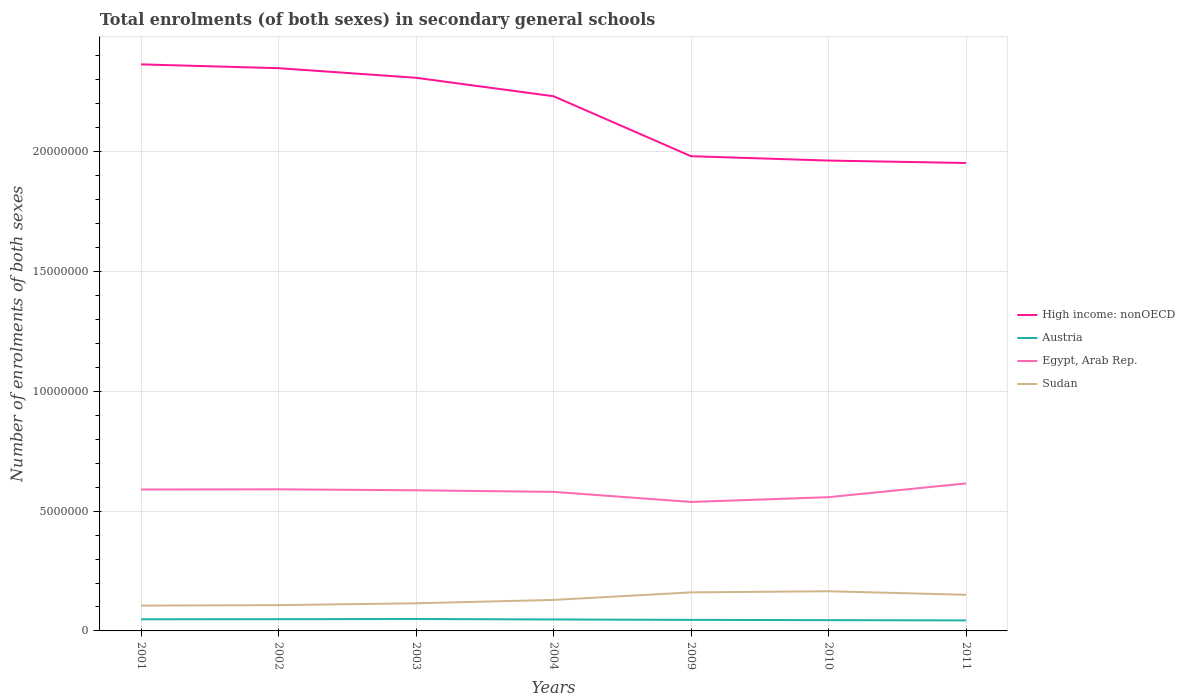How many different coloured lines are there?
Give a very brief answer. 4. Is the number of lines equal to the number of legend labels?
Offer a very short reply. Yes. Across all years, what is the maximum number of enrolments in secondary schools in Egypt, Arab Rep.?
Offer a very short reply. 5.38e+06. What is the total number of enrolments in secondary schools in Sudan in the graph?
Your response must be concise. -4.52e+05. What is the difference between the highest and the second highest number of enrolments in secondary schools in Austria?
Offer a terse response. 5.86e+04. Is the number of enrolments in secondary schools in Sudan strictly greater than the number of enrolments in secondary schools in Egypt, Arab Rep. over the years?
Offer a terse response. Yes. How many lines are there?
Offer a terse response. 4. How many years are there in the graph?
Provide a short and direct response. 7. What is the difference between two consecutive major ticks on the Y-axis?
Keep it short and to the point. 5.00e+06. Are the values on the major ticks of Y-axis written in scientific E-notation?
Your answer should be very brief. No. Where does the legend appear in the graph?
Ensure brevity in your answer.  Center right. How are the legend labels stacked?
Offer a very short reply. Vertical. What is the title of the graph?
Keep it short and to the point. Total enrolments (of both sexes) in secondary general schools. What is the label or title of the X-axis?
Keep it short and to the point. Years. What is the label or title of the Y-axis?
Your answer should be compact. Number of enrolments of both sexes. What is the Number of enrolments of both sexes in High income: nonOECD in 2001?
Give a very brief answer. 2.36e+07. What is the Number of enrolments of both sexes of Austria in 2001?
Give a very brief answer. 4.86e+05. What is the Number of enrolments of both sexes of Egypt, Arab Rep. in 2001?
Keep it short and to the point. 5.90e+06. What is the Number of enrolments of both sexes in Sudan in 2001?
Give a very brief answer. 1.06e+06. What is the Number of enrolments of both sexes in High income: nonOECD in 2002?
Keep it short and to the point. 2.35e+07. What is the Number of enrolments of both sexes in Austria in 2002?
Ensure brevity in your answer.  4.90e+05. What is the Number of enrolments of both sexes of Egypt, Arab Rep. in 2002?
Offer a very short reply. 5.91e+06. What is the Number of enrolments of both sexes of Sudan in 2002?
Keep it short and to the point. 1.08e+06. What is the Number of enrolments of both sexes in High income: nonOECD in 2003?
Ensure brevity in your answer.  2.31e+07. What is the Number of enrolments of both sexes in Austria in 2003?
Give a very brief answer. 4.98e+05. What is the Number of enrolments of both sexes in Egypt, Arab Rep. in 2003?
Provide a short and direct response. 5.87e+06. What is the Number of enrolments of both sexes of Sudan in 2003?
Your answer should be very brief. 1.15e+06. What is the Number of enrolments of both sexes in High income: nonOECD in 2004?
Keep it short and to the point. 2.23e+07. What is the Number of enrolments of both sexes of Austria in 2004?
Your answer should be compact. 4.78e+05. What is the Number of enrolments of both sexes of Egypt, Arab Rep. in 2004?
Your answer should be very brief. 5.80e+06. What is the Number of enrolments of both sexes in Sudan in 2004?
Ensure brevity in your answer.  1.29e+06. What is the Number of enrolments of both sexes of High income: nonOECD in 2009?
Ensure brevity in your answer.  1.98e+07. What is the Number of enrolments of both sexes of Austria in 2009?
Make the answer very short. 4.61e+05. What is the Number of enrolments of both sexes of Egypt, Arab Rep. in 2009?
Provide a succinct answer. 5.38e+06. What is the Number of enrolments of both sexes of Sudan in 2009?
Your answer should be compact. 1.61e+06. What is the Number of enrolments of both sexes in High income: nonOECD in 2010?
Give a very brief answer. 1.96e+07. What is the Number of enrolments of both sexes in Austria in 2010?
Your answer should be very brief. 4.50e+05. What is the Number of enrolments of both sexes in Egypt, Arab Rep. in 2010?
Your response must be concise. 5.58e+06. What is the Number of enrolments of both sexes of Sudan in 2010?
Offer a terse response. 1.66e+06. What is the Number of enrolments of both sexes in High income: nonOECD in 2011?
Provide a short and direct response. 1.95e+07. What is the Number of enrolments of both sexes in Austria in 2011?
Provide a succinct answer. 4.39e+05. What is the Number of enrolments of both sexes of Egypt, Arab Rep. in 2011?
Provide a succinct answer. 6.16e+06. What is the Number of enrolments of both sexes in Sudan in 2011?
Provide a succinct answer. 1.51e+06. Across all years, what is the maximum Number of enrolments of both sexes of High income: nonOECD?
Give a very brief answer. 2.36e+07. Across all years, what is the maximum Number of enrolments of both sexes of Austria?
Make the answer very short. 4.98e+05. Across all years, what is the maximum Number of enrolments of both sexes of Egypt, Arab Rep.?
Your answer should be very brief. 6.16e+06. Across all years, what is the maximum Number of enrolments of both sexes of Sudan?
Make the answer very short. 1.66e+06. Across all years, what is the minimum Number of enrolments of both sexes of High income: nonOECD?
Your answer should be compact. 1.95e+07. Across all years, what is the minimum Number of enrolments of both sexes in Austria?
Your response must be concise. 4.39e+05. Across all years, what is the minimum Number of enrolments of both sexes in Egypt, Arab Rep.?
Offer a terse response. 5.38e+06. Across all years, what is the minimum Number of enrolments of both sexes in Sudan?
Keep it short and to the point. 1.06e+06. What is the total Number of enrolments of both sexes of High income: nonOECD in the graph?
Offer a terse response. 1.52e+08. What is the total Number of enrolments of both sexes of Austria in the graph?
Give a very brief answer. 3.30e+06. What is the total Number of enrolments of both sexes of Egypt, Arab Rep. in the graph?
Provide a short and direct response. 4.06e+07. What is the total Number of enrolments of both sexes of Sudan in the graph?
Provide a short and direct response. 9.35e+06. What is the difference between the Number of enrolments of both sexes in High income: nonOECD in 2001 and that in 2002?
Provide a succinct answer. 1.58e+05. What is the difference between the Number of enrolments of both sexes of Austria in 2001 and that in 2002?
Make the answer very short. -3882. What is the difference between the Number of enrolments of both sexes in Egypt, Arab Rep. in 2001 and that in 2002?
Your answer should be very brief. -7870. What is the difference between the Number of enrolments of both sexes of Sudan in 2001 and that in 2002?
Ensure brevity in your answer.  -2.06e+04. What is the difference between the Number of enrolments of both sexes of High income: nonOECD in 2001 and that in 2003?
Provide a short and direct response. 5.60e+05. What is the difference between the Number of enrolments of both sexes of Austria in 2001 and that in 2003?
Your response must be concise. -1.15e+04. What is the difference between the Number of enrolments of both sexes of Egypt, Arab Rep. in 2001 and that in 2003?
Give a very brief answer. 3.26e+04. What is the difference between the Number of enrolments of both sexes of Sudan in 2001 and that in 2003?
Your response must be concise. -9.72e+04. What is the difference between the Number of enrolments of both sexes of High income: nonOECD in 2001 and that in 2004?
Offer a terse response. 1.33e+06. What is the difference between the Number of enrolments of both sexes of Austria in 2001 and that in 2004?
Keep it short and to the point. 7824. What is the difference between the Number of enrolments of both sexes in Egypt, Arab Rep. in 2001 and that in 2004?
Your answer should be compact. 9.84e+04. What is the difference between the Number of enrolments of both sexes in Sudan in 2001 and that in 2004?
Your answer should be very brief. -2.37e+05. What is the difference between the Number of enrolments of both sexes of High income: nonOECD in 2001 and that in 2009?
Provide a succinct answer. 3.83e+06. What is the difference between the Number of enrolments of both sexes of Austria in 2001 and that in 2009?
Your response must be concise. 2.51e+04. What is the difference between the Number of enrolments of both sexes of Egypt, Arab Rep. in 2001 and that in 2009?
Provide a succinct answer. 5.19e+05. What is the difference between the Number of enrolments of both sexes of Sudan in 2001 and that in 2009?
Give a very brief answer. -5.53e+05. What is the difference between the Number of enrolments of both sexes of High income: nonOECD in 2001 and that in 2010?
Make the answer very short. 4.01e+06. What is the difference between the Number of enrolments of both sexes of Austria in 2001 and that in 2010?
Keep it short and to the point. 3.63e+04. What is the difference between the Number of enrolments of both sexes of Egypt, Arab Rep. in 2001 and that in 2010?
Your response must be concise. 3.20e+05. What is the difference between the Number of enrolments of both sexes of Sudan in 2001 and that in 2010?
Give a very brief answer. -6.00e+05. What is the difference between the Number of enrolments of both sexes of High income: nonOECD in 2001 and that in 2011?
Give a very brief answer. 4.12e+06. What is the difference between the Number of enrolments of both sexes of Austria in 2001 and that in 2011?
Your answer should be very brief. 4.72e+04. What is the difference between the Number of enrolments of both sexes in Egypt, Arab Rep. in 2001 and that in 2011?
Give a very brief answer. -2.54e+05. What is the difference between the Number of enrolments of both sexes in Sudan in 2001 and that in 2011?
Make the answer very short. -4.52e+05. What is the difference between the Number of enrolments of both sexes in High income: nonOECD in 2002 and that in 2003?
Your response must be concise. 4.01e+05. What is the difference between the Number of enrolments of both sexes of Austria in 2002 and that in 2003?
Ensure brevity in your answer.  -7581. What is the difference between the Number of enrolments of both sexes of Egypt, Arab Rep. in 2002 and that in 2003?
Keep it short and to the point. 4.05e+04. What is the difference between the Number of enrolments of both sexes in Sudan in 2002 and that in 2003?
Provide a succinct answer. -7.66e+04. What is the difference between the Number of enrolments of both sexes in High income: nonOECD in 2002 and that in 2004?
Offer a very short reply. 1.17e+06. What is the difference between the Number of enrolments of both sexes of Austria in 2002 and that in 2004?
Provide a succinct answer. 1.17e+04. What is the difference between the Number of enrolments of both sexes of Egypt, Arab Rep. in 2002 and that in 2004?
Your response must be concise. 1.06e+05. What is the difference between the Number of enrolments of both sexes of Sudan in 2002 and that in 2004?
Make the answer very short. -2.17e+05. What is the difference between the Number of enrolments of both sexes of High income: nonOECD in 2002 and that in 2009?
Your answer should be compact. 3.67e+06. What is the difference between the Number of enrolments of both sexes in Austria in 2002 and that in 2009?
Provide a short and direct response. 2.90e+04. What is the difference between the Number of enrolments of both sexes in Egypt, Arab Rep. in 2002 and that in 2009?
Offer a very short reply. 5.27e+05. What is the difference between the Number of enrolments of both sexes in Sudan in 2002 and that in 2009?
Offer a very short reply. -5.32e+05. What is the difference between the Number of enrolments of both sexes of High income: nonOECD in 2002 and that in 2010?
Provide a succinct answer. 3.86e+06. What is the difference between the Number of enrolments of both sexes of Austria in 2002 and that in 2010?
Offer a very short reply. 4.02e+04. What is the difference between the Number of enrolments of both sexes of Egypt, Arab Rep. in 2002 and that in 2010?
Provide a succinct answer. 3.28e+05. What is the difference between the Number of enrolments of both sexes of Sudan in 2002 and that in 2010?
Your response must be concise. -5.79e+05. What is the difference between the Number of enrolments of both sexes in High income: nonOECD in 2002 and that in 2011?
Make the answer very short. 3.96e+06. What is the difference between the Number of enrolments of both sexes of Austria in 2002 and that in 2011?
Your response must be concise. 5.11e+04. What is the difference between the Number of enrolments of both sexes of Egypt, Arab Rep. in 2002 and that in 2011?
Offer a terse response. -2.46e+05. What is the difference between the Number of enrolments of both sexes in Sudan in 2002 and that in 2011?
Provide a succinct answer. -4.32e+05. What is the difference between the Number of enrolments of both sexes of High income: nonOECD in 2003 and that in 2004?
Provide a succinct answer. 7.70e+05. What is the difference between the Number of enrolments of both sexes of Austria in 2003 and that in 2004?
Make the answer very short. 1.93e+04. What is the difference between the Number of enrolments of both sexes of Egypt, Arab Rep. in 2003 and that in 2004?
Provide a short and direct response. 6.57e+04. What is the difference between the Number of enrolments of both sexes in Sudan in 2003 and that in 2004?
Offer a very short reply. -1.40e+05. What is the difference between the Number of enrolments of both sexes in High income: nonOECD in 2003 and that in 2009?
Offer a terse response. 3.27e+06. What is the difference between the Number of enrolments of both sexes in Austria in 2003 and that in 2009?
Make the answer very short. 3.66e+04. What is the difference between the Number of enrolments of both sexes of Egypt, Arab Rep. in 2003 and that in 2009?
Offer a terse response. 4.86e+05. What is the difference between the Number of enrolments of both sexes of Sudan in 2003 and that in 2009?
Your answer should be very brief. -4.55e+05. What is the difference between the Number of enrolments of both sexes in High income: nonOECD in 2003 and that in 2010?
Keep it short and to the point. 3.46e+06. What is the difference between the Number of enrolments of both sexes in Austria in 2003 and that in 2010?
Offer a terse response. 4.78e+04. What is the difference between the Number of enrolments of both sexes of Egypt, Arab Rep. in 2003 and that in 2010?
Offer a terse response. 2.88e+05. What is the difference between the Number of enrolments of both sexes of Sudan in 2003 and that in 2010?
Keep it short and to the point. -5.03e+05. What is the difference between the Number of enrolments of both sexes in High income: nonOECD in 2003 and that in 2011?
Your answer should be very brief. 3.56e+06. What is the difference between the Number of enrolments of both sexes in Austria in 2003 and that in 2011?
Make the answer very short. 5.86e+04. What is the difference between the Number of enrolments of both sexes in Egypt, Arab Rep. in 2003 and that in 2011?
Your answer should be very brief. -2.86e+05. What is the difference between the Number of enrolments of both sexes in Sudan in 2003 and that in 2011?
Your answer should be very brief. -3.55e+05. What is the difference between the Number of enrolments of both sexes in High income: nonOECD in 2004 and that in 2009?
Offer a very short reply. 2.50e+06. What is the difference between the Number of enrolments of both sexes of Austria in 2004 and that in 2009?
Keep it short and to the point. 1.73e+04. What is the difference between the Number of enrolments of both sexes of Egypt, Arab Rep. in 2004 and that in 2009?
Give a very brief answer. 4.21e+05. What is the difference between the Number of enrolments of both sexes in Sudan in 2004 and that in 2009?
Offer a very short reply. -3.15e+05. What is the difference between the Number of enrolments of both sexes of High income: nonOECD in 2004 and that in 2010?
Ensure brevity in your answer.  2.68e+06. What is the difference between the Number of enrolments of both sexes of Austria in 2004 and that in 2010?
Provide a short and direct response. 2.85e+04. What is the difference between the Number of enrolments of both sexes in Egypt, Arab Rep. in 2004 and that in 2010?
Your response must be concise. 2.22e+05. What is the difference between the Number of enrolments of both sexes of Sudan in 2004 and that in 2010?
Make the answer very short. -3.63e+05. What is the difference between the Number of enrolments of both sexes in High income: nonOECD in 2004 and that in 2011?
Your answer should be very brief. 2.79e+06. What is the difference between the Number of enrolments of both sexes in Austria in 2004 and that in 2011?
Provide a short and direct response. 3.94e+04. What is the difference between the Number of enrolments of both sexes in Egypt, Arab Rep. in 2004 and that in 2011?
Your answer should be compact. -3.52e+05. What is the difference between the Number of enrolments of both sexes in Sudan in 2004 and that in 2011?
Make the answer very short. -2.15e+05. What is the difference between the Number of enrolments of both sexes in High income: nonOECD in 2009 and that in 2010?
Provide a succinct answer. 1.82e+05. What is the difference between the Number of enrolments of both sexes of Austria in 2009 and that in 2010?
Ensure brevity in your answer.  1.12e+04. What is the difference between the Number of enrolments of both sexes in Egypt, Arab Rep. in 2009 and that in 2010?
Make the answer very short. -1.99e+05. What is the difference between the Number of enrolments of both sexes in Sudan in 2009 and that in 2010?
Your answer should be compact. -4.73e+04. What is the difference between the Number of enrolments of both sexes of High income: nonOECD in 2009 and that in 2011?
Make the answer very short. 2.83e+05. What is the difference between the Number of enrolments of both sexes of Austria in 2009 and that in 2011?
Keep it short and to the point. 2.21e+04. What is the difference between the Number of enrolments of both sexes in Egypt, Arab Rep. in 2009 and that in 2011?
Your response must be concise. -7.73e+05. What is the difference between the Number of enrolments of both sexes of Sudan in 2009 and that in 2011?
Offer a very short reply. 1.00e+05. What is the difference between the Number of enrolments of both sexes in High income: nonOECD in 2010 and that in 2011?
Ensure brevity in your answer.  1.01e+05. What is the difference between the Number of enrolments of both sexes of Austria in 2010 and that in 2011?
Provide a short and direct response. 1.08e+04. What is the difference between the Number of enrolments of both sexes in Egypt, Arab Rep. in 2010 and that in 2011?
Make the answer very short. -5.74e+05. What is the difference between the Number of enrolments of both sexes in Sudan in 2010 and that in 2011?
Give a very brief answer. 1.48e+05. What is the difference between the Number of enrolments of both sexes in High income: nonOECD in 2001 and the Number of enrolments of both sexes in Austria in 2002?
Keep it short and to the point. 2.32e+07. What is the difference between the Number of enrolments of both sexes in High income: nonOECD in 2001 and the Number of enrolments of both sexes in Egypt, Arab Rep. in 2002?
Keep it short and to the point. 1.77e+07. What is the difference between the Number of enrolments of both sexes of High income: nonOECD in 2001 and the Number of enrolments of both sexes of Sudan in 2002?
Your answer should be very brief. 2.26e+07. What is the difference between the Number of enrolments of both sexes of Austria in 2001 and the Number of enrolments of both sexes of Egypt, Arab Rep. in 2002?
Give a very brief answer. -5.42e+06. What is the difference between the Number of enrolments of both sexes in Austria in 2001 and the Number of enrolments of both sexes in Sudan in 2002?
Offer a terse response. -5.91e+05. What is the difference between the Number of enrolments of both sexes of Egypt, Arab Rep. in 2001 and the Number of enrolments of both sexes of Sudan in 2002?
Offer a very short reply. 4.83e+06. What is the difference between the Number of enrolments of both sexes in High income: nonOECD in 2001 and the Number of enrolments of both sexes in Austria in 2003?
Your answer should be compact. 2.32e+07. What is the difference between the Number of enrolments of both sexes of High income: nonOECD in 2001 and the Number of enrolments of both sexes of Egypt, Arab Rep. in 2003?
Your response must be concise. 1.78e+07. What is the difference between the Number of enrolments of both sexes in High income: nonOECD in 2001 and the Number of enrolments of both sexes in Sudan in 2003?
Provide a short and direct response. 2.25e+07. What is the difference between the Number of enrolments of both sexes of Austria in 2001 and the Number of enrolments of both sexes of Egypt, Arab Rep. in 2003?
Give a very brief answer. -5.38e+06. What is the difference between the Number of enrolments of both sexes of Austria in 2001 and the Number of enrolments of both sexes of Sudan in 2003?
Provide a succinct answer. -6.67e+05. What is the difference between the Number of enrolments of both sexes in Egypt, Arab Rep. in 2001 and the Number of enrolments of both sexes in Sudan in 2003?
Provide a succinct answer. 4.75e+06. What is the difference between the Number of enrolments of both sexes of High income: nonOECD in 2001 and the Number of enrolments of both sexes of Austria in 2004?
Make the answer very short. 2.32e+07. What is the difference between the Number of enrolments of both sexes in High income: nonOECD in 2001 and the Number of enrolments of both sexes in Egypt, Arab Rep. in 2004?
Give a very brief answer. 1.78e+07. What is the difference between the Number of enrolments of both sexes of High income: nonOECD in 2001 and the Number of enrolments of both sexes of Sudan in 2004?
Your answer should be compact. 2.24e+07. What is the difference between the Number of enrolments of both sexes in Austria in 2001 and the Number of enrolments of both sexes in Egypt, Arab Rep. in 2004?
Provide a succinct answer. -5.32e+06. What is the difference between the Number of enrolments of both sexes of Austria in 2001 and the Number of enrolments of both sexes of Sudan in 2004?
Keep it short and to the point. -8.08e+05. What is the difference between the Number of enrolments of both sexes in Egypt, Arab Rep. in 2001 and the Number of enrolments of both sexes in Sudan in 2004?
Ensure brevity in your answer.  4.61e+06. What is the difference between the Number of enrolments of both sexes of High income: nonOECD in 2001 and the Number of enrolments of both sexes of Austria in 2009?
Give a very brief answer. 2.32e+07. What is the difference between the Number of enrolments of both sexes of High income: nonOECD in 2001 and the Number of enrolments of both sexes of Egypt, Arab Rep. in 2009?
Make the answer very short. 1.83e+07. What is the difference between the Number of enrolments of both sexes of High income: nonOECD in 2001 and the Number of enrolments of both sexes of Sudan in 2009?
Your response must be concise. 2.20e+07. What is the difference between the Number of enrolments of both sexes of Austria in 2001 and the Number of enrolments of both sexes of Egypt, Arab Rep. in 2009?
Make the answer very short. -4.90e+06. What is the difference between the Number of enrolments of both sexes in Austria in 2001 and the Number of enrolments of both sexes in Sudan in 2009?
Provide a short and direct response. -1.12e+06. What is the difference between the Number of enrolments of both sexes of Egypt, Arab Rep. in 2001 and the Number of enrolments of both sexes of Sudan in 2009?
Ensure brevity in your answer.  4.29e+06. What is the difference between the Number of enrolments of both sexes of High income: nonOECD in 2001 and the Number of enrolments of both sexes of Austria in 2010?
Your response must be concise. 2.32e+07. What is the difference between the Number of enrolments of both sexes in High income: nonOECD in 2001 and the Number of enrolments of both sexes in Egypt, Arab Rep. in 2010?
Your answer should be compact. 1.81e+07. What is the difference between the Number of enrolments of both sexes in High income: nonOECD in 2001 and the Number of enrolments of both sexes in Sudan in 2010?
Give a very brief answer. 2.20e+07. What is the difference between the Number of enrolments of both sexes of Austria in 2001 and the Number of enrolments of both sexes of Egypt, Arab Rep. in 2010?
Offer a very short reply. -5.10e+06. What is the difference between the Number of enrolments of both sexes in Austria in 2001 and the Number of enrolments of both sexes in Sudan in 2010?
Keep it short and to the point. -1.17e+06. What is the difference between the Number of enrolments of both sexes of Egypt, Arab Rep. in 2001 and the Number of enrolments of both sexes of Sudan in 2010?
Offer a terse response. 4.25e+06. What is the difference between the Number of enrolments of both sexes in High income: nonOECD in 2001 and the Number of enrolments of both sexes in Austria in 2011?
Your answer should be very brief. 2.32e+07. What is the difference between the Number of enrolments of both sexes of High income: nonOECD in 2001 and the Number of enrolments of both sexes of Egypt, Arab Rep. in 2011?
Your response must be concise. 1.75e+07. What is the difference between the Number of enrolments of both sexes in High income: nonOECD in 2001 and the Number of enrolments of both sexes in Sudan in 2011?
Your answer should be very brief. 2.21e+07. What is the difference between the Number of enrolments of both sexes of Austria in 2001 and the Number of enrolments of both sexes of Egypt, Arab Rep. in 2011?
Provide a succinct answer. -5.67e+06. What is the difference between the Number of enrolments of both sexes in Austria in 2001 and the Number of enrolments of both sexes in Sudan in 2011?
Your answer should be compact. -1.02e+06. What is the difference between the Number of enrolments of both sexes of Egypt, Arab Rep. in 2001 and the Number of enrolments of both sexes of Sudan in 2011?
Your answer should be compact. 4.39e+06. What is the difference between the Number of enrolments of both sexes in High income: nonOECD in 2002 and the Number of enrolments of both sexes in Austria in 2003?
Offer a very short reply. 2.30e+07. What is the difference between the Number of enrolments of both sexes of High income: nonOECD in 2002 and the Number of enrolments of both sexes of Egypt, Arab Rep. in 2003?
Offer a terse response. 1.76e+07. What is the difference between the Number of enrolments of both sexes in High income: nonOECD in 2002 and the Number of enrolments of both sexes in Sudan in 2003?
Provide a succinct answer. 2.23e+07. What is the difference between the Number of enrolments of both sexes in Austria in 2002 and the Number of enrolments of both sexes in Egypt, Arab Rep. in 2003?
Keep it short and to the point. -5.38e+06. What is the difference between the Number of enrolments of both sexes of Austria in 2002 and the Number of enrolments of both sexes of Sudan in 2003?
Ensure brevity in your answer.  -6.64e+05. What is the difference between the Number of enrolments of both sexes in Egypt, Arab Rep. in 2002 and the Number of enrolments of both sexes in Sudan in 2003?
Your response must be concise. 4.76e+06. What is the difference between the Number of enrolments of both sexes in High income: nonOECD in 2002 and the Number of enrolments of both sexes in Austria in 2004?
Your answer should be very brief. 2.30e+07. What is the difference between the Number of enrolments of both sexes in High income: nonOECD in 2002 and the Number of enrolments of both sexes in Egypt, Arab Rep. in 2004?
Offer a very short reply. 1.77e+07. What is the difference between the Number of enrolments of both sexes of High income: nonOECD in 2002 and the Number of enrolments of both sexes of Sudan in 2004?
Your response must be concise. 2.22e+07. What is the difference between the Number of enrolments of both sexes of Austria in 2002 and the Number of enrolments of both sexes of Egypt, Arab Rep. in 2004?
Your response must be concise. -5.31e+06. What is the difference between the Number of enrolments of both sexes of Austria in 2002 and the Number of enrolments of both sexes of Sudan in 2004?
Provide a succinct answer. -8.04e+05. What is the difference between the Number of enrolments of both sexes of Egypt, Arab Rep. in 2002 and the Number of enrolments of both sexes of Sudan in 2004?
Your answer should be very brief. 4.62e+06. What is the difference between the Number of enrolments of both sexes in High income: nonOECD in 2002 and the Number of enrolments of both sexes in Austria in 2009?
Ensure brevity in your answer.  2.30e+07. What is the difference between the Number of enrolments of both sexes in High income: nonOECD in 2002 and the Number of enrolments of both sexes in Egypt, Arab Rep. in 2009?
Your answer should be compact. 1.81e+07. What is the difference between the Number of enrolments of both sexes of High income: nonOECD in 2002 and the Number of enrolments of both sexes of Sudan in 2009?
Offer a very short reply. 2.19e+07. What is the difference between the Number of enrolments of both sexes of Austria in 2002 and the Number of enrolments of both sexes of Egypt, Arab Rep. in 2009?
Offer a very short reply. -4.89e+06. What is the difference between the Number of enrolments of both sexes of Austria in 2002 and the Number of enrolments of both sexes of Sudan in 2009?
Ensure brevity in your answer.  -1.12e+06. What is the difference between the Number of enrolments of both sexes of Egypt, Arab Rep. in 2002 and the Number of enrolments of both sexes of Sudan in 2009?
Your response must be concise. 4.30e+06. What is the difference between the Number of enrolments of both sexes of High income: nonOECD in 2002 and the Number of enrolments of both sexes of Austria in 2010?
Provide a short and direct response. 2.30e+07. What is the difference between the Number of enrolments of both sexes of High income: nonOECD in 2002 and the Number of enrolments of both sexes of Egypt, Arab Rep. in 2010?
Keep it short and to the point. 1.79e+07. What is the difference between the Number of enrolments of both sexes of High income: nonOECD in 2002 and the Number of enrolments of both sexes of Sudan in 2010?
Your answer should be compact. 2.18e+07. What is the difference between the Number of enrolments of both sexes in Austria in 2002 and the Number of enrolments of both sexes in Egypt, Arab Rep. in 2010?
Make the answer very short. -5.09e+06. What is the difference between the Number of enrolments of both sexes of Austria in 2002 and the Number of enrolments of both sexes of Sudan in 2010?
Your answer should be very brief. -1.17e+06. What is the difference between the Number of enrolments of both sexes of Egypt, Arab Rep. in 2002 and the Number of enrolments of both sexes of Sudan in 2010?
Your response must be concise. 4.25e+06. What is the difference between the Number of enrolments of both sexes of High income: nonOECD in 2002 and the Number of enrolments of both sexes of Austria in 2011?
Provide a short and direct response. 2.31e+07. What is the difference between the Number of enrolments of both sexes in High income: nonOECD in 2002 and the Number of enrolments of both sexes in Egypt, Arab Rep. in 2011?
Offer a terse response. 1.73e+07. What is the difference between the Number of enrolments of both sexes of High income: nonOECD in 2002 and the Number of enrolments of both sexes of Sudan in 2011?
Keep it short and to the point. 2.20e+07. What is the difference between the Number of enrolments of both sexes of Austria in 2002 and the Number of enrolments of both sexes of Egypt, Arab Rep. in 2011?
Offer a very short reply. -5.67e+06. What is the difference between the Number of enrolments of both sexes in Austria in 2002 and the Number of enrolments of both sexes in Sudan in 2011?
Your answer should be compact. -1.02e+06. What is the difference between the Number of enrolments of both sexes in Egypt, Arab Rep. in 2002 and the Number of enrolments of both sexes in Sudan in 2011?
Make the answer very short. 4.40e+06. What is the difference between the Number of enrolments of both sexes in High income: nonOECD in 2003 and the Number of enrolments of both sexes in Austria in 2004?
Give a very brief answer. 2.26e+07. What is the difference between the Number of enrolments of both sexes in High income: nonOECD in 2003 and the Number of enrolments of both sexes in Egypt, Arab Rep. in 2004?
Ensure brevity in your answer.  1.73e+07. What is the difference between the Number of enrolments of both sexes in High income: nonOECD in 2003 and the Number of enrolments of both sexes in Sudan in 2004?
Your answer should be very brief. 2.18e+07. What is the difference between the Number of enrolments of both sexes of Austria in 2003 and the Number of enrolments of both sexes of Egypt, Arab Rep. in 2004?
Ensure brevity in your answer.  -5.31e+06. What is the difference between the Number of enrolments of both sexes of Austria in 2003 and the Number of enrolments of both sexes of Sudan in 2004?
Offer a terse response. -7.96e+05. What is the difference between the Number of enrolments of both sexes in Egypt, Arab Rep. in 2003 and the Number of enrolments of both sexes in Sudan in 2004?
Your answer should be very brief. 4.58e+06. What is the difference between the Number of enrolments of both sexes in High income: nonOECD in 2003 and the Number of enrolments of both sexes in Austria in 2009?
Your answer should be compact. 2.26e+07. What is the difference between the Number of enrolments of both sexes in High income: nonOECD in 2003 and the Number of enrolments of both sexes in Egypt, Arab Rep. in 2009?
Ensure brevity in your answer.  1.77e+07. What is the difference between the Number of enrolments of both sexes of High income: nonOECD in 2003 and the Number of enrolments of both sexes of Sudan in 2009?
Ensure brevity in your answer.  2.15e+07. What is the difference between the Number of enrolments of both sexes of Austria in 2003 and the Number of enrolments of both sexes of Egypt, Arab Rep. in 2009?
Provide a short and direct response. -4.89e+06. What is the difference between the Number of enrolments of both sexes in Austria in 2003 and the Number of enrolments of both sexes in Sudan in 2009?
Your answer should be compact. -1.11e+06. What is the difference between the Number of enrolments of both sexes of Egypt, Arab Rep. in 2003 and the Number of enrolments of both sexes of Sudan in 2009?
Your answer should be compact. 4.26e+06. What is the difference between the Number of enrolments of both sexes in High income: nonOECD in 2003 and the Number of enrolments of both sexes in Austria in 2010?
Provide a succinct answer. 2.26e+07. What is the difference between the Number of enrolments of both sexes in High income: nonOECD in 2003 and the Number of enrolments of both sexes in Egypt, Arab Rep. in 2010?
Make the answer very short. 1.75e+07. What is the difference between the Number of enrolments of both sexes in High income: nonOECD in 2003 and the Number of enrolments of both sexes in Sudan in 2010?
Your answer should be compact. 2.14e+07. What is the difference between the Number of enrolments of both sexes of Austria in 2003 and the Number of enrolments of both sexes of Egypt, Arab Rep. in 2010?
Provide a succinct answer. -5.08e+06. What is the difference between the Number of enrolments of both sexes of Austria in 2003 and the Number of enrolments of both sexes of Sudan in 2010?
Provide a short and direct response. -1.16e+06. What is the difference between the Number of enrolments of both sexes of Egypt, Arab Rep. in 2003 and the Number of enrolments of both sexes of Sudan in 2010?
Make the answer very short. 4.21e+06. What is the difference between the Number of enrolments of both sexes of High income: nonOECD in 2003 and the Number of enrolments of both sexes of Austria in 2011?
Offer a very short reply. 2.26e+07. What is the difference between the Number of enrolments of both sexes in High income: nonOECD in 2003 and the Number of enrolments of both sexes in Egypt, Arab Rep. in 2011?
Keep it short and to the point. 1.69e+07. What is the difference between the Number of enrolments of both sexes of High income: nonOECD in 2003 and the Number of enrolments of both sexes of Sudan in 2011?
Provide a short and direct response. 2.16e+07. What is the difference between the Number of enrolments of both sexes of Austria in 2003 and the Number of enrolments of both sexes of Egypt, Arab Rep. in 2011?
Provide a succinct answer. -5.66e+06. What is the difference between the Number of enrolments of both sexes in Austria in 2003 and the Number of enrolments of both sexes in Sudan in 2011?
Offer a terse response. -1.01e+06. What is the difference between the Number of enrolments of both sexes in Egypt, Arab Rep. in 2003 and the Number of enrolments of both sexes in Sudan in 2011?
Offer a terse response. 4.36e+06. What is the difference between the Number of enrolments of both sexes in High income: nonOECD in 2004 and the Number of enrolments of both sexes in Austria in 2009?
Provide a short and direct response. 2.19e+07. What is the difference between the Number of enrolments of both sexes of High income: nonOECD in 2004 and the Number of enrolments of both sexes of Egypt, Arab Rep. in 2009?
Offer a very short reply. 1.69e+07. What is the difference between the Number of enrolments of both sexes in High income: nonOECD in 2004 and the Number of enrolments of both sexes in Sudan in 2009?
Provide a succinct answer. 2.07e+07. What is the difference between the Number of enrolments of both sexes in Austria in 2004 and the Number of enrolments of both sexes in Egypt, Arab Rep. in 2009?
Give a very brief answer. -4.91e+06. What is the difference between the Number of enrolments of both sexes in Austria in 2004 and the Number of enrolments of both sexes in Sudan in 2009?
Your answer should be very brief. -1.13e+06. What is the difference between the Number of enrolments of both sexes of Egypt, Arab Rep. in 2004 and the Number of enrolments of both sexes of Sudan in 2009?
Provide a succinct answer. 4.20e+06. What is the difference between the Number of enrolments of both sexes of High income: nonOECD in 2004 and the Number of enrolments of both sexes of Austria in 2010?
Offer a terse response. 2.19e+07. What is the difference between the Number of enrolments of both sexes in High income: nonOECD in 2004 and the Number of enrolments of both sexes in Egypt, Arab Rep. in 2010?
Your answer should be very brief. 1.67e+07. What is the difference between the Number of enrolments of both sexes in High income: nonOECD in 2004 and the Number of enrolments of both sexes in Sudan in 2010?
Offer a very short reply. 2.07e+07. What is the difference between the Number of enrolments of both sexes in Austria in 2004 and the Number of enrolments of both sexes in Egypt, Arab Rep. in 2010?
Give a very brief answer. -5.10e+06. What is the difference between the Number of enrolments of both sexes of Austria in 2004 and the Number of enrolments of both sexes of Sudan in 2010?
Your answer should be very brief. -1.18e+06. What is the difference between the Number of enrolments of both sexes of Egypt, Arab Rep. in 2004 and the Number of enrolments of both sexes of Sudan in 2010?
Your answer should be very brief. 4.15e+06. What is the difference between the Number of enrolments of both sexes in High income: nonOECD in 2004 and the Number of enrolments of both sexes in Austria in 2011?
Your answer should be very brief. 2.19e+07. What is the difference between the Number of enrolments of both sexes of High income: nonOECD in 2004 and the Number of enrolments of both sexes of Egypt, Arab Rep. in 2011?
Your response must be concise. 1.62e+07. What is the difference between the Number of enrolments of both sexes in High income: nonOECD in 2004 and the Number of enrolments of both sexes in Sudan in 2011?
Your response must be concise. 2.08e+07. What is the difference between the Number of enrolments of both sexes of Austria in 2004 and the Number of enrolments of both sexes of Egypt, Arab Rep. in 2011?
Your answer should be very brief. -5.68e+06. What is the difference between the Number of enrolments of both sexes of Austria in 2004 and the Number of enrolments of both sexes of Sudan in 2011?
Provide a succinct answer. -1.03e+06. What is the difference between the Number of enrolments of both sexes of Egypt, Arab Rep. in 2004 and the Number of enrolments of both sexes of Sudan in 2011?
Provide a succinct answer. 4.30e+06. What is the difference between the Number of enrolments of both sexes in High income: nonOECD in 2009 and the Number of enrolments of both sexes in Austria in 2010?
Give a very brief answer. 1.94e+07. What is the difference between the Number of enrolments of both sexes of High income: nonOECD in 2009 and the Number of enrolments of both sexes of Egypt, Arab Rep. in 2010?
Provide a short and direct response. 1.42e+07. What is the difference between the Number of enrolments of both sexes of High income: nonOECD in 2009 and the Number of enrolments of both sexes of Sudan in 2010?
Ensure brevity in your answer.  1.82e+07. What is the difference between the Number of enrolments of both sexes of Austria in 2009 and the Number of enrolments of both sexes of Egypt, Arab Rep. in 2010?
Provide a succinct answer. -5.12e+06. What is the difference between the Number of enrolments of both sexes in Austria in 2009 and the Number of enrolments of both sexes in Sudan in 2010?
Your answer should be very brief. -1.20e+06. What is the difference between the Number of enrolments of both sexes of Egypt, Arab Rep. in 2009 and the Number of enrolments of both sexes of Sudan in 2010?
Ensure brevity in your answer.  3.73e+06. What is the difference between the Number of enrolments of both sexes of High income: nonOECD in 2009 and the Number of enrolments of both sexes of Austria in 2011?
Offer a terse response. 1.94e+07. What is the difference between the Number of enrolments of both sexes of High income: nonOECD in 2009 and the Number of enrolments of both sexes of Egypt, Arab Rep. in 2011?
Ensure brevity in your answer.  1.37e+07. What is the difference between the Number of enrolments of both sexes of High income: nonOECD in 2009 and the Number of enrolments of both sexes of Sudan in 2011?
Make the answer very short. 1.83e+07. What is the difference between the Number of enrolments of both sexes of Austria in 2009 and the Number of enrolments of both sexes of Egypt, Arab Rep. in 2011?
Your response must be concise. -5.70e+06. What is the difference between the Number of enrolments of both sexes in Austria in 2009 and the Number of enrolments of both sexes in Sudan in 2011?
Your answer should be very brief. -1.05e+06. What is the difference between the Number of enrolments of both sexes in Egypt, Arab Rep. in 2009 and the Number of enrolments of both sexes in Sudan in 2011?
Make the answer very short. 3.88e+06. What is the difference between the Number of enrolments of both sexes in High income: nonOECD in 2010 and the Number of enrolments of both sexes in Austria in 2011?
Give a very brief answer. 1.92e+07. What is the difference between the Number of enrolments of both sexes of High income: nonOECD in 2010 and the Number of enrolments of both sexes of Egypt, Arab Rep. in 2011?
Your response must be concise. 1.35e+07. What is the difference between the Number of enrolments of both sexes of High income: nonOECD in 2010 and the Number of enrolments of both sexes of Sudan in 2011?
Provide a succinct answer. 1.81e+07. What is the difference between the Number of enrolments of both sexes of Austria in 2010 and the Number of enrolments of both sexes of Egypt, Arab Rep. in 2011?
Keep it short and to the point. -5.71e+06. What is the difference between the Number of enrolments of both sexes in Austria in 2010 and the Number of enrolments of both sexes in Sudan in 2011?
Your answer should be compact. -1.06e+06. What is the difference between the Number of enrolments of both sexes of Egypt, Arab Rep. in 2010 and the Number of enrolments of both sexes of Sudan in 2011?
Provide a succinct answer. 4.07e+06. What is the average Number of enrolments of both sexes in High income: nonOECD per year?
Your answer should be very brief. 2.16e+07. What is the average Number of enrolments of both sexes of Austria per year?
Your answer should be very brief. 4.72e+05. What is the average Number of enrolments of both sexes of Egypt, Arab Rep. per year?
Give a very brief answer. 5.80e+06. What is the average Number of enrolments of both sexes of Sudan per year?
Make the answer very short. 1.34e+06. In the year 2001, what is the difference between the Number of enrolments of both sexes in High income: nonOECD and Number of enrolments of both sexes in Austria?
Keep it short and to the point. 2.32e+07. In the year 2001, what is the difference between the Number of enrolments of both sexes in High income: nonOECD and Number of enrolments of both sexes in Egypt, Arab Rep.?
Offer a terse response. 1.77e+07. In the year 2001, what is the difference between the Number of enrolments of both sexes in High income: nonOECD and Number of enrolments of both sexes in Sudan?
Offer a very short reply. 2.26e+07. In the year 2001, what is the difference between the Number of enrolments of both sexes of Austria and Number of enrolments of both sexes of Egypt, Arab Rep.?
Offer a very short reply. -5.42e+06. In the year 2001, what is the difference between the Number of enrolments of both sexes of Austria and Number of enrolments of both sexes of Sudan?
Make the answer very short. -5.70e+05. In the year 2001, what is the difference between the Number of enrolments of both sexes of Egypt, Arab Rep. and Number of enrolments of both sexes of Sudan?
Give a very brief answer. 4.85e+06. In the year 2002, what is the difference between the Number of enrolments of both sexes in High income: nonOECD and Number of enrolments of both sexes in Austria?
Your response must be concise. 2.30e+07. In the year 2002, what is the difference between the Number of enrolments of both sexes in High income: nonOECD and Number of enrolments of both sexes in Egypt, Arab Rep.?
Ensure brevity in your answer.  1.76e+07. In the year 2002, what is the difference between the Number of enrolments of both sexes of High income: nonOECD and Number of enrolments of both sexes of Sudan?
Offer a terse response. 2.24e+07. In the year 2002, what is the difference between the Number of enrolments of both sexes of Austria and Number of enrolments of both sexes of Egypt, Arab Rep.?
Ensure brevity in your answer.  -5.42e+06. In the year 2002, what is the difference between the Number of enrolments of both sexes of Austria and Number of enrolments of both sexes of Sudan?
Ensure brevity in your answer.  -5.87e+05. In the year 2002, what is the difference between the Number of enrolments of both sexes in Egypt, Arab Rep. and Number of enrolments of both sexes in Sudan?
Your answer should be compact. 4.83e+06. In the year 2003, what is the difference between the Number of enrolments of both sexes of High income: nonOECD and Number of enrolments of both sexes of Austria?
Offer a terse response. 2.26e+07. In the year 2003, what is the difference between the Number of enrolments of both sexes of High income: nonOECD and Number of enrolments of both sexes of Egypt, Arab Rep.?
Your answer should be compact. 1.72e+07. In the year 2003, what is the difference between the Number of enrolments of both sexes in High income: nonOECD and Number of enrolments of both sexes in Sudan?
Offer a very short reply. 2.19e+07. In the year 2003, what is the difference between the Number of enrolments of both sexes of Austria and Number of enrolments of both sexes of Egypt, Arab Rep.?
Offer a terse response. -5.37e+06. In the year 2003, what is the difference between the Number of enrolments of both sexes in Austria and Number of enrolments of both sexes in Sudan?
Your answer should be compact. -6.56e+05. In the year 2003, what is the difference between the Number of enrolments of both sexes of Egypt, Arab Rep. and Number of enrolments of both sexes of Sudan?
Your response must be concise. 4.72e+06. In the year 2004, what is the difference between the Number of enrolments of both sexes in High income: nonOECD and Number of enrolments of both sexes in Austria?
Ensure brevity in your answer.  2.18e+07. In the year 2004, what is the difference between the Number of enrolments of both sexes of High income: nonOECD and Number of enrolments of both sexes of Egypt, Arab Rep.?
Keep it short and to the point. 1.65e+07. In the year 2004, what is the difference between the Number of enrolments of both sexes of High income: nonOECD and Number of enrolments of both sexes of Sudan?
Your answer should be compact. 2.10e+07. In the year 2004, what is the difference between the Number of enrolments of both sexes in Austria and Number of enrolments of both sexes in Egypt, Arab Rep.?
Your answer should be compact. -5.33e+06. In the year 2004, what is the difference between the Number of enrolments of both sexes of Austria and Number of enrolments of both sexes of Sudan?
Offer a terse response. -8.15e+05. In the year 2004, what is the difference between the Number of enrolments of both sexes of Egypt, Arab Rep. and Number of enrolments of both sexes of Sudan?
Offer a very short reply. 4.51e+06. In the year 2009, what is the difference between the Number of enrolments of both sexes of High income: nonOECD and Number of enrolments of both sexes of Austria?
Give a very brief answer. 1.94e+07. In the year 2009, what is the difference between the Number of enrolments of both sexes in High income: nonOECD and Number of enrolments of both sexes in Egypt, Arab Rep.?
Your answer should be compact. 1.44e+07. In the year 2009, what is the difference between the Number of enrolments of both sexes of High income: nonOECD and Number of enrolments of both sexes of Sudan?
Your answer should be compact. 1.82e+07. In the year 2009, what is the difference between the Number of enrolments of both sexes in Austria and Number of enrolments of both sexes in Egypt, Arab Rep.?
Offer a terse response. -4.92e+06. In the year 2009, what is the difference between the Number of enrolments of both sexes of Austria and Number of enrolments of both sexes of Sudan?
Provide a short and direct response. -1.15e+06. In the year 2009, what is the difference between the Number of enrolments of both sexes in Egypt, Arab Rep. and Number of enrolments of both sexes in Sudan?
Offer a terse response. 3.77e+06. In the year 2010, what is the difference between the Number of enrolments of both sexes of High income: nonOECD and Number of enrolments of both sexes of Austria?
Offer a very short reply. 1.92e+07. In the year 2010, what is the difference between the Number of enrolments of both sexes of High income: nonOECD and Number of enrolments of both sexes of Egypt, Arab Rep.?
Ensure brevity in your answer.  1.41e+07. In the year 2010, what is the difference between the Number of enrolments of both sexes of High income: nonOECD and Number of enrolments of both sexes of Sudan?
Offer a very short reply. 1.80e+07. In the year 2010, what is the difference between the Number of enrolments of both sexes in Austria and Number of enrolments of both sexes in Egypt, Arab Rep.?
Provide a succinct answer. -5.13e+06. In the year 2010, what is the difference between the Number of enrolments of both sexes of Austria and Number of enrolments of both sexes of Sudan?
Offer a very short reply. -1.21e+06. In the year 2010, what is the difference between the Number of enrolments of both sexes in Egypt, Arab Rep. and Number of enrolments of both sexes in Sudan?
Provide a succinct answer. 3.93e+06. In the year 2011, what is the difference between the Number of enrolments of both sexes of High income: nonOECD and Number of enrolments of both sexes of Austria?
Give a very brief answer. 1.91e+07. In the year 2011, what is the difference between the Number of enrolments of both sexes of High income: nonOECD and Number of enrolments of both sexes of Egypt, Arab Rep.?
Provide a short and direct response. 1.34e+07. In the year 2011, what is the difference between the Number of enrolments of both sexes in High income: nonOECD and Number of enrolments of both sexes in Sudan?
Keep it short and to the point. 1.80e+07. In the year 2011, what is the difference between the Number of enrolments of both sexes of Austria and Number of enrolments of both sexes of Egypt, Arab Rep.?
Provide a short and direct response. -5.72e+06. In the year 2011, what is the difference between the Number of enrolments of both sexes in Austria and Number of enrolments of both sexes in Sudan?
Offer a very short reply. -1.07e+06. In the year 2011, what is the difference between the Number of enrolments of both sexes in Egypt, Arab Rep. and Number of enrolments of both sexes in Sudan?
Keep it short and to the point. 4.65e+06. What is the ratio of the Number of enrolments of both sexes in High income: nonOECD in 2001 to that in 2002?
Offer a terse response. 1.01. What is the ratio of the Number of enrolments of both sexes in Egypt, Arab Rep. in 2001 to that in 2002?
Give a very brief answer. 1. What is the ratio of the Number of enrolments of both sexes of Sudan in 2001 to that in 2002?
Keep it short and to the point. 0.98. What is the ratio of the Number of enrolments of both sexes of High income: nonOECD in 2001 to that in 2003?
Offer a very short reply. 1.02. What is the ratio of the Number of enrolments of both sexes of Austria in 2001 to that in 2003?
Your answer should be very brief. 0.98. What is the ratio of the Number of enrolments of both sexes in Egypt, Arab Rep. in 2001 to that in 2003?
Ensure brevity in your answer.  1.01. What is the ratio of the Number of enrolments of both sexes in Sudan in 2001 to that in 2003?
Keep it short and to the point. 0.92. What is the ratio of the Number of enrolments of both sexes in High income: nonOECD in 2001 to that in 2004?
Provide a succinct answer. 1.06. What is the ratio of the Number of enrolments of both sexes of Austria in 2001 to that in 2004?
Provide a short and direct response. 1.02. What is the ratio of the Number of enrolments of both sexes of Egypt, Arab Rep. in 2001 to that in 2004?
Give a very brief answer. 1.02. What is the ratio of the Number of enrolments of both sexes of Sudan in 2001 to that in 2004?
Offer a very short reply. 0.82. What is the ratio of the Number of enrolments of both sexes in High income: nonOECD in 2001 to that in 2009?
Your answer should be very brief. 1.19. What is the ratio of the Number of enrolments of both sexes of Austria in 2001 to that in 2009?
Give a very brief answer. 1.05. What is the ratio of the Number of enrolments of both sexes in Egypt, Arab Rep. in 2001 to that in 2009?
Provide a succinct answer. 1.1. What is the ratio of the Number of enrolments of both sexes in Sudan in 2001 to that in 2009?
Keep it short and to the point. 0.66. What is the ratio of the Number of enrolments of both sexes of High income: nonOECD in 2001 to that in 2010?
Make the answer very short. 1.2. What is the ratio of the Number of enrolments of both sexes in Austria in 2001 to that in 2010?
Keep it short and to the point. 1.08. What is the ratio of the Number of enrolments of both sexes in Egypt, Arab Rep. in 2001 to that in 2010?
Your answer should be compact. 1.06. What is the ratio of the Number of enrolments of both sexes of Sudan in 2001 to that in 2010?
Your response must be concise. 0.64. What is the ratio of the Number of enrolments of both sexes of High income: nonOECD in 2001 to that in 2011?
Keep it short and to the point. 1.21. What is the ratio of the Number of enrolments of both sexes in Austria in 2001 to that in 2011?
Make the answer very short. 1.11. What is the ratio of the Number of enrolments of both sexes of Egypt, Arab Rep. in 2001 to that in 2011?
Offer a very short reply. 0.96. What is the ratio of the Number of enrolments of both sexes in Sudan in 2001 to that in 2011?
Keep it short and to the point. 0.7. What is the ratio of the Number of enrolments of both sexes in High income: nonOECD in 2002 to that in 2003?
Ensure brevity in your answer.  1.02. What is the ratio of the Number of enrolments of both sexes of Austria in 2002 to that in 2003?
Make the answer very short. 0.98. What is the ratio of the Number of enrolments of both sexes in Sudan in 2002 to that in 2003?
Provide a succinct answer. 0.93. What is the ratio of the Number of enrolments of both sexes in High income: nonOECD in 2002 to that in 2004?
Offer a terse response. 1.05. What is the ratio of the Number of enrolments of both sexes in Austria in 2002 to that in 2004?
Offer a terse response. 1.02. What is the ratio of the Number of enrolments of both sexes of Egypt, Arab Rep. in 2002 to that in 2004?
Ensure brevity in your answer.  1.02. What is the ratio of the Number of enrolments of both sexes in Sudan in 2002 to that in 2004?
Offer a terse response. 0.83. What is the ratio of the Number of enrolments of both sexes of High income: nonOECD in 2002 to that in 2009?
Your answer should be very brief. 1.19. What is the ratio of the Number of enrolments of both sexes in Austria in 2002 to that in 2009?
Your answer should be very brief. 1.06. What is the ratio of the Number of enrolments of both sexes of Egypt, Arab Rep. in 2002 to that in 2009?
Make the answer very short. 1.1. What is the ratio of the Number of enrolments of both sexes in Sudan in 2002 to that in 2009?
Your answer should be very brief. 0.67. What is the ratio of the Number of enrolments of both sexes in High income: nonOECD in 2002 to that in 2010?
Offer a very short reply. 1.2. What is the ratio of the Number of enrolments of both sexes of Austria in 2002 to that in 2010?
Your answer should be very brief. 1.09. What is the ratio of the Number of enrolments of both sexes of Egypt, Arab Rep. in 2002 to that in 2010?
Offer a terse response. 1.06. What is the ratio of the Number of enrolments of both sexes in Sudan in 2002 to that in 2010?
Your response must be concise. 0.65. What is the ratio of the Number of enrolments of both sexes in High income: nonOECD in 2002 to that in 2011?
Keep it short and to the point. 1.2. What is the ratio of the Number of enrolments of both sexes in Austria in 2002 to that in 2011?
Provide a short and direct response. 1.12. What is the ratio of the Number of enrolments of both sexes of Egypt, Arab Rep. in 2002 to that in 2011?
Give a very brief answer. 0.96. What is the ratio of the Number of enrolments of both sexes of Sudan in 2002 to that in 2011?
Your response must be concise. 0.71. What is the ratio of the Number of enrolments of both sexes in High income: nonOECD in 2003 to that in 2004?
Provide a succinct answer. 1.03. What is the ratio of the Number of enrolments of both sexes in Austria in 2003 to that in 2004?
Offer a very short reply. 1.04. What is the ratio of the Number of enrolments of both sexes in Egypt, Arab Rep. in 2003 to that in 2004?
Your answer should be very brief. 1.01. What is the ratio of the Number of enrolments of both sexes of Sudan in 2003 to that in 2004?
Your answer should be compact. 0.89. What is the ratio of the Number of enrolments of both sexes in High income: nonOECD in 2003 to that in 2009?
Give a very brief answer. 1.17. What is the ratio of the Number of enrolments of both sexes of Austria in 2003 to that in 2009?
Make the answer very short. 1.08. What is the ratio of the Number of enrolments of both sexes in Egypt, Arab Rep. in 2003 to that in 2009?
Offer a terse response. 1.09. What is the ratio of the Number of enrolments of both sexes in Sudan in 2003 to that in 2009?
Provide a succinct answer. 0.72. What is the ratio of the Number of enrolments of both sexes in High income: nonOECD in 2003 to that in 2010?
Your response must be concise. 1.18. What is the ratio of the Number of enrolments of both sexes of Austria in 2003 to that in 2010?
Make the answer very short. 1.11. What is the ratio of the Number of enrolments of both sexes of Egypt, Arab Rep. in 2003 to that in 2010?
Ensure brevity in your answer.  1.05. What is the ratio of the Number of enrolments of both sexes of Sudan in 2003 to that in 2010?
Keep it short and to the point. 0.7. What is the ratio of the Number of enrolments of both sexes of High income: nonOECD in 2003 to that in 2011?
Your answer should be very brief. 1.18. What is the ratio of the Number of enrolments of both sexes in Austria in 2003 to that in 2011?
Ensure brevity in your answer.  1.13. What is the ratio of the Number of enrolments of both sexes in Egypt, Arab Rep. in 2003 to that in 2011?
Offer a terse response. 0.95. What is the ratio of the Number of enrolments of both sexes of Sudan in 2003 to that in 2011?
Your response must be concise. 0.76. What is the ratio of the Number of enrolments of both sexes of High income: nonOECD in 2004 to that in 2009?
Your answer should be compact. 1.13. What is the ratio of the Number of enrolments of both sexes of Austria in 2004 to that in 2009?
Make the answer very short. 1.04. What is the ratio of the Number of enrolments of both sexes of Egypt, Arab Rep. in 2004 to that in 2009?
Give a very brief answer. 1.08. What is the ratio of the Number of enrolments of both sexes in Sudan in 2004 to that in 2009?
Your response must be concise. 0.8. What is the ratio of the Number of enrolments of both sexes of High income: nonOECD in 2004 to that in 2010?
Keep it short and to the point. 1.14. What is the ratio of the Number of enrolments of both sexes in Austria in 2004 to that in 2010?
Provide a short and direct response. 1.06. What is the ratio of the Number of enrolments of both sexes in Egypt, Arab Rep. in 2004 to that in 2010?
Your answer should be compact. 1.04. What is the ratio of the Number of enrolments of both sexes in Sudan in 2004 to that in 2010?
Your response must be concise. 0.78. What is the ratio of the Number of enrolments of both sexes in High income: nonOECD in 2004 to that in 2011?
Keep it short and to the point. 1.14. What is the ratio of the Number of enrolments of both sexes of Austria in 2004 to that in 2011?
Offer a terse response. 1.09. What is the ratio of the Number of enrolments of both sexes of Egypt, Arab Rep. in 2004 to that in 2011?
Keep it short and to the point. 0.94. What is the ratio of the Number of enrolments of both sexes of Sudan in 2004 to that in 2011?
Make the answer very short. 0.86. What is the ratio of the Number of enrolments of both sexes of High income: nonOECD in 2009 to that in 2010?
Offer a terse response. 1.01. What is the ratio of the Number of enrolments of both sexes of Austria in 2009 to that in 2010?
Your answer should be very brief. 1.02. What is the ratio of the Number of enrolments of both sexes in Egypt, Arab Rep. in 2009 to that in 2010?
Make the answer very short. 0.96. What is the ratio of the Number of enrolments of both sexes in Sudan in 2009 to that in 2010?
Make the answer very short. 0.97. What is the ratio of the Number of enrolments of both sexes of High income: nonOECD in 2009 to that in 2011?
Ensure brevity in your answer.  1.01. What is the ratio of the Number of enrolments of both sexes in Austria in 2009 to that in 2011?
Your answer should be very brief. 1.05. What is the ratio of the Number of enrolments of both sexes of Egypt, Arab Rep. in 2009 to that in 2011?
Provide a succinct answer. 0.87. What is the ratio of the Number of enrolments of both sexes in Sudan in 2009 to that in 2011?
Make the answer very short. 1.07. What is the ratio of the Number of enrolments of both sexes in High income: nonOECD in 2010 to that in 2011?
Give a very brief answer. 1.01. What is the ratio of the Number of enrolments of both sexes of Austria in 2010 to that in 2011?
Your answer should be compact. 1.02. What is the ratio of the Number of enrolments of both sexes of Egypt, Arab Rep. in 2010 to that in 2011?
Ensure brevity in your answer.  0.91. What is the ratio of the Number of enrolments of both sexes of Sudan in 2010 to that in 2011?
Keep it short and to the point. 1.1. What is the difference between the highest and the second highest Number of enrolments of both sexes in High income: nonOECD?
Keep it short and to the point. 1.58e+05. What is the difference between the highest and the second highest Number of enrolments of both sexes in Austria?
Provide a succinct answer. 7581. What is the difference between the highest and the second highest Number of enrolments of both sexes of Egypt, Arab Rep.?
Offer a very short reply. 2.46e+05. What is the difference between the highest and the second highest Number of enrolments of both sexes of Sudan?
Offer a terse response. 4.73e+04. What is the difference between the highest and the lowest Number of enrolments of both sexes in High income: nonOECD?
Ensure brevity in your answer.  4.12e+06. What is the difference between the highest and the lowest Number of enrolments of both sexes of Austria?
Make the answer very short. 5.86e+04. What is the difference between the highest and the lowest Number of enrolments of both sexes of Egypt, Arab Rep.?
Ensure brevity in your answer.  7.73e+05. What is the difference between the highest and the lowest Number of enrolments of both sexes of Sudan?
Make the answer very short. 6.00e+05. 